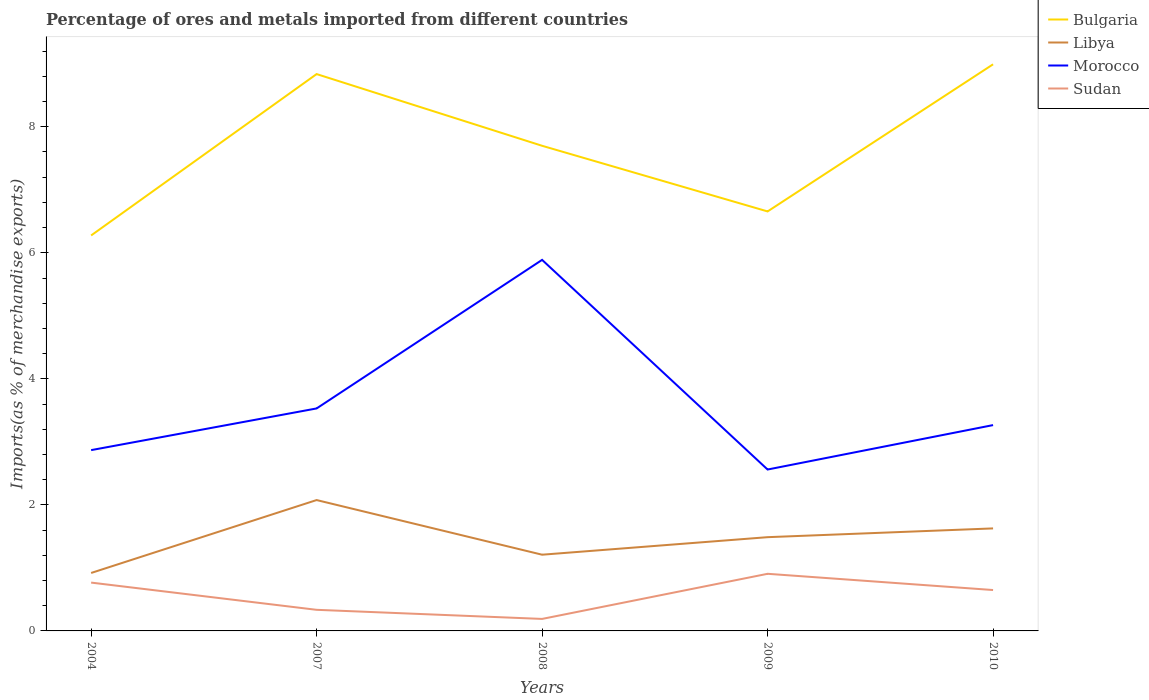Does the line corresponding to Morocco intersect with the line corresponding to Libya?
Offer a very short reply. No. Across all years, what is the maximum percentage of imports to different countries in Morocco?
Provide a succinct answer. 2.56. What is the total percentage of imports to different countries in Sudan in the graph?
Provide a short and direct response. 0.58. What is the difference between the highest and the second highest percentage of imports to different countries in Libya?
Offer a very short reply. 1.16. How many lines are there?
Your answer should be compact. 4. How many years are there in the graph?
Provide a succinct answer. 5. How many legend labels are there?
Make the answer very short. 4. What is the title of the graph?
Your response must be concise. Percentage of ores and metals imported from different countries. What is the label or title of the X-axis?
Give a very brief answer. Years. What is the label or title of the Y-axis?
Offer a terse response. Imports(as % of merchandise exports). What is the Imports(as % of merchandise exports) of Bulgaria in 2004?
Make the answer very short. 6.28. What is the Imports(as % of merchandise exports) in Libya in 2004?
Keep it short and to the point. 0.92. What is the Imports(as % of merchandise exports) of Morocco in 2004?
Offer a terse response. 2.87. What is the Imports(as % of merchandise exports) of Sudan in 2004?
Ensure brevity in your answer.  0.77. What is the Imports(as % of merchandise exports) of Bulgaria in 2007?
Give a very brief answer. 8.84. What is the Imports(as % of merchandise exports) of Libya in 2007?
Keep it short and to the point. 2.08. What is the Imports(as % of merchandise exports) of Morocco in 2007?
Offer a very short reply. 3.53. What is the Imports(as % of merchandise exports) in Sudan in 2007?
Provide a short and direct response. 0.33. What is the Imports(as % of merchandise exports) in Bulgaria in 2008?
Provide a short and direct response. 7.7. What is the Imports(as % of merchandise exports) of Libya in 2008?
Your answer should be very brief. 1.21. What is the Imports(as % of merchandise exports) in Morocco in 2008?
Keep it short and to the point. 5.89. What is the Imports(as % of merchandise exports) in Sudan in 2008?
Provide a short and direct response. 0.19. What is the Imports(as % of merchandise exports) in Bulgaria in 2009?
Provide a succinct answer. 6.66. What is the Imports(as % of merchandise exports) in Libya in 2009?
Provide a succinct answer. 1.49. What is the Imports(as % of merchandise exports) in Morocco in 2009?
Give a very brief answer. 2.56. What is the Imports(as % of merchandise exports) of Sudan in 2009?
Provide a short and direct response. 0.91. What is the Imports(as % of merchandise exports) of Bulgaria in 2010?
Provide a short and direct response. 8.99. What is the Imports(as % of merchandise exports) in Libya in 2010?
Your response must be concise. 1.63. What is the Imports(as % of merchandise exports) of Morocco in 2010?
Your response must be concise. 3.27. What is the Imports(as % of merchandise exports) of Sudan in 2010?
Give a very brief answer. 0.65. Across all years, what is the maximum Imports(as % of merchandise exports) of Bulgaria?
Your response must be concise. 8.99. Across all years, what is the maximum Imports(as % of merchandise exports) of Libya?
Ensure brevity in your answer.  2.08. Across all years, what is the maximum Imports(as % of merchandise exports) of Morocco?
Provide a short and direct response. 5.89. Across all years, what is the maximum Imports(as % of merchandise exports) of Sudan?
Your answer should be very brief. 0.91. Across all years, what is the minimum Imports(as % of merchandise exports) in Bulgaria?
Provide a short and direct response. 6.28. Across all years, what is the minimum Imports(as % of merchandise exports) of Libya?
Make the answer very short. 0.92. Across all years, what is the minimum Imports(as % of merchandise exports) in Morocco?
Offer a terse response. 2.56. Across all years, what is the minimum Imports(as % of merchandise exports) of Sudan?
Offer a very short reply. 0.19. What is the total Imports(as % of merchandise exports) in Bulgaria in the graph?
Your answer should be compact. 38.46. What is the total Imports(as % of merchandise exports) in Libya in the graph?
Offer a very short reply. 7.32. What is the total Imports(as % of merchandise exports) of Morocco in the graph?
Offer a terse response. 18.11. What is the total Imports(as % of merchandise exports) of Sudan in the graph?
Your response must be concise. 2.85. What is the difference between the Imports(as % of merchandise exports) of Bulgaria in 2004 and that in 2007?
Provide a short and direct response. -2.56. What is the difference between the Imports(as % of merchandise exports) in Libya in 2004 and that in 2007?
Your answer should be very brief. -1.16. What is the difference between the Imports(as % of merchandise exports) of Morocco in 2004 and that in 2007?
Your response must be concise. -0.66. What is the difference between the Imports(as % of merchandise exports) in Sudan in 2004 and that in 2007?
Your answer should be compact. 0.43. What is the difference between the Imports(as % of merchandise exports) in Bulgaria in 2004 and that in 2008?
Keep it short and to the point. -1.42. What is the difference between the Imports(as % of merchandise exports) of Libya in 2004 and that in 2008?
Ensure brevity in your answer.  -0.29. What is the difference between the Imports(as % of merchandise exports) of Morocco in 2004 and that in 2008?
Your answer should be very brief. -3.02. What is the difference between the Imports(as % of merchandise exports) of Sudan in 2004 and that in 2008?
Provide a succinct answer. 0.58. What is the difference between the Imports(as % of merchandise exports) of Bulgaria in 2004 and that in 2009?
Offer a very short reply. -0.38. What is the difference between the Imports(as % of merchandise exports) in Libya in 2004 and that in 2009?
Offer a terse response. -0.57. What is the difference between the Imports(as % of merchandise exports) in Morocco in 2004 and that in 2009?
Your answer should be compact. 0.31. What is the difference between the Imports(as % of merchandise exports) of Sudan in 2004 and that in 2009?
Provide a short and direct response. -0.14. What is the difference between the Imports(as % of merchandise exports) in Bulgaria in 2004 and that in 2010?
Offer a very short reply. -2.72. What is the difference between the Imports(as % of merchandise exports) in Libya in 2004 and that in 2010?
Provide a short and direct response. -0.71. What is the difference between the Imports(as % of merchandise exports) of Morocco in 2004 and that in 2010?
Make the answer very short. -0.4. What is the difference between the Imports(as % of merchandise exports) in Sudan in 2004 and that in 2010?
Your answer should be compact. 0.12. What is the difference between the Imports(as % of merchandise exports) of Bulgaria in 2007 and that in 2008?
Ensure brevity in your answer.  1.14. What is the difference between the Imports(as % of merchandise exports) of Libya in 2007 and that in 2008?
Ensure brevity in your answer.  0.87. What is the difference between the Imports(as % of merchandise exports) of Morocco in 2007 and that in 2008?
Offer a very short reply. -2.36. What is the difference between the Imports(as % of merchandise exports) in Sudan in 2007 and that in 2008?
Your answer should be compact. 0.14. What is the difference between the Imports(as % of merchandise exports) in Bulgaria in 2007 and that in 2009?
Offer a very short reply. 2.18. What is the difference between the Imports(as % of merchandise exports) of Libya in 2007 and that in 2009?
Give a very brief answer. 0.59. What is the difference between the Imports(as % of merchandise exports) of Morocco in 2007 and that in 2009?
Ensure brevity in your answer.  0.97. What is the difference between the Imports(as % of merchandise exports) in Sudan in 2007 and that in 2009?
Your answer should be very brief. -0.57. What is the difference between the Imports(as % of merchandise exports) of Bulgaria in 2007 and that in 2010?
Give a very brief answer. -0.16. What is the difference between the Imports(as % of merchandise exports) in Libya in 2007 and that in 2010?
Offer a terse response. 0.45. What is the difference between the Imports(as % of merchandise exports) of Morocco in 2007 and that in 2010?
Your response must be concise. 0.26. What is the difference between the Imports(as % of merchandise exports) in Sudan in 2007 and that in 2010?
Offer a terse response. -0.31. What is the difference between the Imports(as % of merchandise exports) in Bulgaria in 2008 and that in 2009?
Your response must be concise. 1.04. What is the difference between the Imports(as % of merchandise exports) in Libya in 2008 and that in 2009?
Ensure brevity in your answer.  -0.28. What is the difference between the Imports(as % of merchandise exports) in Morocco in 2008 and that in 2009?
Keep it short and to the point. 3.33. What is the difference between the Imports(as % of merchandise exports) of Sudan in 2008 and that in 2009?
Provide a short and direct response. -0.72. What is the difference between the Imports(as % of merchandise exports) of Bulgaria in 2008 and that in 2010?
Offer a very short reply. -1.29. What is the difference between the Imports(as % of merchandise exports) of Libya in 2008 and that in 2010?
Your answer should be very brief. -0.42. What is the difference between the Imports(as % of merchandise exports) in Morocco in 2008 and that in 2010?
Give a very brief answer. 2.62. What is the difference between the Imports(as % of merchandise exports) in Sudan in 2008 and that in 2010?
Provide a succinct answer. -0.46. What is the difference between the Imports(as % of merchandise exports) of Bulgaria in 2009 and that in 2010?
Give a very brief answer. -2.33. What is the difference between the Imports(as % of merchandise exports) of Libya in 2009 and that in 2010?
Your answer should be very brief. -0.14. What is the difference between the Imports(as % of merchandise exports) of Morocco in 2009 and that in 2010?
Your response must be concise. -0.7. What is the difference between the Imports(as % of merchandise exports) of Sudan in 2009 and that in 2010?
Keep it short and to the point. 0.26. What is the difference between the Imports(as % of merchandise exports) in Bulgaria in 2004 and the Imports(as % of merchandise exports) in Libya in 2007?
Offer a very short reply. 4.2. What is the difference between the Imports(as % of merchandise exports) in Bulgaria in 2004 and the Imports(as % of merchandise exports) in Morocco in 2007?
Provide a succinct answer. 2.74. What is the difference between the Imports(as % of merchandise exports) of Bulgaria in 2004 and the Imports(as % of merchandise exports) of Sudan in 2007?
Offer a very short reply. 5.94. What is the difference between the Imports(as % of merchandise exports) of Libya in 2004 and the Imports(as % of merchandise exports) of Morocco in 2007?
Give a very brief answer. -2.61. What is the difference between the Imports(as % of merchandise exports) in Libya in 2004 and the Imports(as % of merchandise exports) in Sudan in 2007?
Your answer should be very brief. 0.58. What is the difference between the Imports(as % of merchandise exports) of Morocco in 2004 and the Imports(as % of merchandise exports) of Sudan in 2007?
Your response must be concise. 2.53. What is the difference between the Imports(as % of merchandise exports) in Bulgaria in 2004 and the Imports(as % of merchandise exports) in Libya in 2008?
Your answer should be very brief. 5.07. What is the difference between the Imports(as % of merchandise exports) in Bulgaria in 2004 and the Imports(as % of merchandise exports) in Morocco in 2008?
Your answer should be very brief. 0.39. What is the difference between the Imports(as % of merchandise exports) in Bulgaria in 2004 and the Imports(as % of merchandise exports) in Sudan in 2008?
Ensure brevity in your answer.  6.08. What is the difference between the Imports(as % of merchandise exports) in Libya in 2004 and the Imports(as % of merchandise exports) in Morocco in 2008?
Offer a terse response. -4.97. What is the difference between the Imports(as % of merchandise exports) of Libya in 2004 and the Imports(as % of merchandise exports) of Sudan in 2008?
Offer a very short reply. 0.73. What is the difference between the Imports(as % of merchandise exports) in Morocco in 2004 and the Imports(as % of merchandise exports) in Sudan in 2008?
Offer a terse response. 2.68. What is the difference between the Imports(as % of merchandise exports) in Bulgaria in 2004 and the Imports(as % of merchandise exports) in Libya in 2009?
Offer a terse response. 4.79. What is the difference between the Imports(as % of merchandise exports) of Bulgaria in 2004 and the Imports(as % of merchandise exports) of Morocco in 2009?
Offer a terse response. 3.71. What is the difference between the Imports(as % of merchandise exports) of Bulgaria in 2004 and the Imports(as % of merchandise exports) of Sudan in 2009?
Offer a very short reply. 5.37. What is the difference between the Imports(as % of merchandise exports) in Libya in 2004 and the Imports(as % of merchandise exports) in Morocco in 2009?
Give a very brief answer. -1.64. What is the difference between the Imports(as % of merchandise exports) of Libya in 2004 and the Imports(as % of merchandise exports) of Sudan in 2009?
Ensure brevity in your answer.  0.01. What is the difference between the Imports(as % of merchandise exports) in Morocco in 2004 and the Imports(as % of merchandise exports) in Sudan in 2009?
Your answer should be very brief. 1.96. What is the difference between the Imports(as % of merchandise exports) in Bulgaria in 2004 and the Imports(as % of merchandise exports) in Libya in 2010?
Keep it short and to the point. 4.65. What is the difference between the Imports(as % of merchandise exports) in Bulgaria in 2004 and the Imports(as % of merchandise exports) in Morocco in 2010?
Keep it short and to the point. 3.01. What is the difference between the Imports(as % of merchandise exports) of Bulgaria in 2004 and the Imports(as % of merchandise exports) of Sudan in 2010?
Make the answer very short. 5.63. What is the difference between the Imports(as % of merchandise exports) of Libya in 2004 and the Imports(as % of merchandise exports) of Morocco in 2010?
Make the answer very short. -2.35. What is the difference between the Imports(as % of merchandise exports) in Libya in 2004 and the Imports(as % of merchandise exports) in Sudan in 2010?
Ensure brevity in your answer.  0.27. What is the difference between the Imports(as % of merchandise exports) of Morocco in 2004 and the Imports(as % of merchandise exports) of Sudan in 2010?
Keep it short and to the point. 2.22. What is the difference between the Imports(as % of merchandise exports) of Bulgaria in 2007 and the Imports(as % of merchandise exports) of Libya in 2008?
Give a very brief answer. 7.63. What is the difference between the Imports(as % of merchandise exports) of Bulgaria in 2007 and the Imports(as % of merchandise exports) of Morocco in 2008?
Ensure brevity in your answer.  2.95. What is the difference between the Imports(as % of merchandise exports) of Bulgaria in 2007 and the Imports(as % of merchandise exports) of Sudan in 2008?
Your response must be concise. 8.65. What is the difference between the Imports(as % of merchandise exports) of Libya in 2007 and the Imports(as % of merchandise exports) of Morocco in 2008?
Provide a short and direct response. -3.81. What is the difference between the Imports(as % of merchandise exports) of Libya in 2007 and the Imports(as % of merchandise exports) of Sudan in 2008?
Offer a terse response. 1.89. What is the difference between the Imports(as % of merchandise exports) in Morocco in 2007 and the Imports(as % of merchandise exports) in Sudan in 2008?
Give a very brief answer. 3.34. What is the difference between the Imports(as % of merchandise exports) in Bulgaria in 2007 and the Imports(as % of merchandise exports) in Libya in 2009?
Provide a short and direct response. 7.35. What is the difference between the Imports(as % of merchandise exports) of Bulgaria in 2007 and the Imports(as % of merchandise exports) of Morocco in 2009?
Provide a short and direct response. 6.27. What is the difference between the Imports(as % of merchandise exports) of Bulgaria in 2007 and the Imports(as % of merchandise exports) of Sudan in 2009?
Keep it short and to the point. 7.93. What is the difference between the Imports(as % of merchandise exports) of Libya in 2007 and the Imports(as % of merchandise exports) of Morocco in 2009?
Provide a succinct answer. -0.48. What is the difference between the Imports(as % of merchandise exports) of Libya in 2007 and the Imports(as % of merchandise exports) of Sudan in 2009?
Provide a succinct answer. 1.17. What is the difference between the Imports(as % of merchandise exports) in Morocco in 2007 and the Imports(as % of merchandise exports) in Sudan in 2009?
Give a very brief answer. 2.62. What is the difference between the Imports(as % of merchandise exports) in Bulgaria in 2007 and the Imports(as % of merchandise exports) in Libya in 2010?
Offer a terse response. 7.21. What is the difference between the Imports(as % of merchandise exports) in Bulgaria in 2007 and the Imports(as % of merchandise exports) in Morocco in 2010?
Provide a succinct answer. 5.57. What is the difference between the Imports(as % of merchandise exports) in Bulgaria in 2007 and the Imports(as % of merchandise exports) in Sudan in 2010?
Ensure brevity in your answer.  8.19. What is the difference between the Imports(as % of merchandise exports) in Libya in 2007 and the Imports(as % of merchandise exports) in Morocco in 2010?
Offer a very short reply. -1.19. What is the difference between the Imports(as % of merchandise exports) in Libya in 2007 and the Imports(as % of merchandise exports) in Sudan in 2010?
Provide a short and direct response. 1.43. What is the difference between the Imports(as % of merchandise exports) in Morocco in 2007 and the Imports(as % of merchandise exports) in Sudan in 2010?
Provide a short and direct response. 2.88. What is the difference between the Imports(as % of merchandise exports) of Bulgaria in 2008 and the Imports(as % of merchandise exports) of Libya in 2009?
Offer a terse response. 6.21. What is the difference between the Imports(as % of merchandise exports) of Bulgaria in 2008 and the Imports(as % of merchandise exports) of Morocco in 2009?
Provide a succinct answer. 5.14. What is the difference between the Imports(as % of merchandise exports) in Bulgaria in 2008 and the Imports(as % of merchandise exports) in Sudan in 2009?
Keep it short and to the point. 6.79. What is the difference between the Imports(as % of merchandise exports) of Libya in 2008 and the Imports(as % of merchandise exports) of Morocco in 2009?
Your response must be concise. -1.35. What is the difference between the Imports(as % of merchandise exports) of Libya in 2008 and the Imports(as % of merchandise exports) of Sudan in 2009?
Give a very brief answer. 0.3. What is the difference between the Imports(as % of merchandise exports) in Morocco in 2008 and the Imports(as % of merchandise exports) in Sudan in 2009?
Provide a short and direct response. 4.98. What is the difference between the Imports(as % of merchandise exports) of Bulgaria in 2008 and the Imports(as % of merchandise exports) of Libya in 2010?
Your response must be concise. 6.07. What is the difference between the Imports(as % of merchandise exports) in Bulgaria in 2008 and the Imports(as % of merchandise exports) in Morocco in 2010?
Your answer should be compact. 4.43. What is the difference between the Imports(as % of merchandise exports) of Bulgaria in 2008 and the Imports(as % of merchandise exports) of Sudan in 2010?
Ensure brevity in your answer.  7.05. What is the difference between the Imports(as % of merchandise exports) of Libya in 2008 and the Imports(as % of merchandise exports) of Morocco in 2010?
Make the answer very short. -2.06. What is the difference between the Imports(as % of merchandise exports) in Libya in 2008 and the Imports(as % of merchandise exports) in Sudan in 2010?
Your response must be concise. 0.56. What is the difference between the Imports(as % of merchandise exports) of Morocco in 2008 and the Imports(as % of merchandise exports) of Sudan in 2010?
Provide a succinct answer. 5.24. What is the difference between the Imports(as % of merchandise exports) of Bulgaria in 2009 and the Imports(as % of merchandise exports) of Libya in 2010?
Your answer should be very brief. 5.03. What is the difference between the Imports(as % of merchandise exports) in Bulgaria in 2009 and the Imports(as % of merchandise exports) in Morocco in 2010?
Make the answer very short. 3.39. What is the difference between the Imports(as % of merchandise exports) in Bulgaria in 2009 and the Imports(as % of merchandise exports) in Sudan in 2010?
Provide a short and direct response. 6.01. What is the difference between the Imports(as % of merchandise exports) in Libya in 2009 and the Imports(as % of merchandise exports) in Morocco in 2010?
Keep it short and to the point. -1.78. What is the difference between the Imports(as % of merchandise exports) in Libya in 2009 and the Imports(as % of merchandise exports) in Sudan in 2010?
Offer a very short reply. 0.84. What is the difference between the Imports(as % of merchandise exports) of Morocco in 2009 and the Imports(as % of merchandise exports) of Sudan in 2010?
Make the answer very short. 1.91. What is the average Imports(as % of merchandise exports) in Bulgaria per year?
Offer a terse response. 7.69. What is the average Imports(as % of merchandise exports) of Libya per year?
Give a very brief answer. 1.46. What is the average Imports(as % of merchandise exports) in Morocco per year?
Provide a succinct answer. 3.62. What is the average Imports(as % of merchandise exports) of Sudan per year?
Your answer should be compact. 0.57. In the year 2004, what is the difference between the Imports(as % of merchandise exports) of Bulgaria and Imports(as % of merchandise exports) of Libya?
Your answer should be very brief. 5.36. In the year 2004, what is the difference between the Imports(as % of merchandise exports) of Bulgaria and Imports(as % of merchandise exports) of Morocco?
Give a very brief answer. 3.41. In the year 2004, what is the difference between the Imports(as % of merchandise exports) of Bulgaria and Imports(as % of merchandise exports) of Sudan?
Provide a succinct answer. 5.51. In the year 2004, what is the difference between the Imports(as % of merchandise exports) of Libya and Imports(as % of merchandise exports) of Morocco?
Ensure brevity in your answer.  -1.95. In the year 2004, what is the difference between the Imports(as % of merchandise exports) of Libya and Imports(as % of merchandise exports) of Sudan?
Give a very brief answer. 0.15. In the year 2004, what is the difference between the Imports(as % of merchandise exports) of Morocco and Imports(as % of merchandise exports) of Sudan?
Your answer should be very brief. 2.1. In the year 2007, what is the difference between the Imports(as % of merchandise exports) in Bulgaria and Imports(as % of merchandise exports) in Libya?
Your response must be concise. 6.76. In the year 2007, what is the difference between the Imports(as % of merchandise exports) in Bulgaria and Imports(as % of merchandise exports) in Morocco?
Offer a very short reply. 5.31. In the year 2007, what is the difference between the Imports(as % of merchandise exports) in Bulgaria and Imports(as % of merchandise exports) in Sudan?
Your answer should be very brief. 8.5. In the year 2007, what is the difference between the Imports(as % of merchandise exports) in Libya and Imports(as % of merchandise exports) in Morocco?
Offer a very short reply. -1.45. In the year 2007, what is the difference between the Imports(as % of merchandise exports) of Libya and Imports(as % of merchandise exports) of Sudan?
Ensure brevity in your answer.  1.74. In the year 2007, what is the difference between the Imports(as % of merchandise exports) of Morocco and Imports(as % of merchandise exports) of Sudan?
Keep it short and to the point. 3.2. In the year 2008, what is the difference between the Imports(as % of merchandise exports) in Bulgaria and Imports(as % of merchandise exports) in Libya?
Keep it short and to the point. 6.49. In the year 2008, what is the difference between the Imports(as % of merchandise exports) of Bulgaria and Imports(as % of merchandise exports) of Morocco?
Offer a terse response. 1.81. In the year 2008, what is the difference between the Imports(as % of merchandise exports) in Bulgaria and Imports(as % of merchandise exports) in Sudan?
Ensure brevity in your answer.  7.51. In the year 2008, what is the difference between the Imports(as % of merchandise exports) of Libya and Imports(as % of merchandise exports) of Morocco?
Offer a terse response. -4.68. In the year 2008, what is the difference between the Imports(as % of merchandise exports) in Morocco and Imports(as % of merchandise exports) in Sudan?
Provide a short and direct response. 5.7. In the year 2009, what is the difference between the Imports(as % of merchandise exports) of Bulgaria and Imports(as % of merchandise exports) of Libya?
Provide a succinct answer. 5.17. In the year 2009, what is the difference between the Imports(as % of merchandise exports) of Bulgaria and Imports(as % of merchandise exports) of Morocco?
Make the answer very short. 4.1. In the year 2009, what is the difference between the Imports(as % of merchandise exports) in Bulgaria and Imports(as % of merchandise exports) in Sudan?
Provide a short and direct response. 5.75. In the year 2009, what is the difference between the Imports(as % of merchandise exports) of Libya and Imports(as % of merchandise exports) of Morocco?
Keep it short and to the point. -1.07. In the year 2009, what is the difference between the Imports(as % of merchandise exports) of Libya and Imports(as % of merchandise exports) of Sudan?
Make the answer very short. 0.58. In the year 2009, what is the difference between the Imports(as % of merchandise exports) of Morocco and Imports(as % of merchandise exports) of Sudan?
Provide a short and direct response. 1.65. In the year 2010, what is the difference between the Imports(as % of merchandise exports) in Bulgaria and Imports(as % of merchandise exports) in Libya?
Your response must be concise. 7.36. In the year 2010, what is the difference between the Imports(as % of merchandise exports) of Bulgaria and Imports(as % of merchandise exports) of Morocco?
Your answer should be compact. 5.72. In the year 2010, what is the difference between the Imports(as % of merchandise exports) in Bulgaria and Imports(as % of merchandise exports) in Sudan?
Make the answer very short. 8.34. In the year 2010, what is the difference between the Imports(as % of merchandise exports) of Libya and Imports(as % of merchandise exports) of Morocco?
Your answer should be very brief. -1.64. In the year 2010, what is the difference between the Imports(as % of merchandise exports) of Libya and Imports(as % of merchandise exports) of Sudan?
Provide a succinct answer. 0.98. In the year 2010, what is the difference between the Imports(as % of merchandise exports) in Morocco and Imports(as % of merchandise exports) in Sudan?
Your answer should be very brief. 2.62. What is the ratio of the Imports(as % of merchandise exports) in Bulgaria in 2004 to that in 2007?
Your answer should be compact. 0.71. What is the ratio of the Imports(as % of merchandise exports) in Libya in 2004 to that in 2007?
Provide a short and direct response. 0.44. What is the ratio of the Imports(as % of merchandise exports) in Morocco in 2004 to that in 2007?
Make the answer very short. 0.81. What is the ratio of the Imports(as % of merchandise exports) of Sudan in 2004 to that in 2007?
Ensure brevity in your answer.  2.29. What is the ratio of the Imports(as % of merchandise exports) of Bulgaria in 2004 to that in 2008?
Provide a short and direct response. 0.82. What is the ratio of the Imports(as % of merchandise exports) in Libya in 2004 to that in 2008?
Provide a short and direct response. 0.76. What is the ratio of the Imports(as % of merchandise exports) in Morocco in 2004 to that in 2008?
Offer a terse response. 0.49. What is the ratio of the Imports(as % of merchandise exports) in Sudan in 2004 to that in 2008?
Your answer should be compact. 4.03. What is the ratio of the Imports(as % of merchandise exports) of Bulgaria in 2004 to that in 2009?
Give a very brief answer. 0.94. What is the ratio of the Imports(as % of merchandise exports) of Libya in 2004 to that in 2009?
Your answer should be compact. 0.62. What is the ratio of the Imports(as % of merchandise exports) in Morocco in 2004 to that in 2009?
Your response must be concise. 1.12. What is the ratio of the Imports(as % of merchandise exports) in Sudan in 2004 to that in 2009?
Your answer should be compact. 0.85. What is the ratio of the Imports(as % of merchandise exports) of Bulgaria in 2004 to that in 2010?
Ensure brevity in your answer.  0.7. What is the ratio of the Imports(as % of merchandise exports) of Libya in 2004 to that in 2010?
Give a very brief answer. 0.57. What is the ratio of the Imports(as % of merchandise exports) of Morocco in 2004 to that in 2010?
Give a very brief answer. 0.88. What is the ratio of the Imports(as % of merchandise exports) of Sudan in 2004 to that in 2010?
Your response must be concise. 1.18. What is the ratio of the Imports(as % of merchandise exports) of Bulgaria in 2007 to that in 2008?
Provide a short and direct response. 1.15. What is the ratio of the Imports(as % of merchandise exports) in Libya in 2007 to that in 2008?
Your answer should be very brief. 1.72. What is the ratio of the Imports(as % of merchandise exports) of Morocco in 2007 to that in 2008?
Your answer should be very brief. 0.6. What is the ratio of the Imports(as % of merchandise exports) in Sudan in 2007 to that in 2008?
Offer a very short reply. 1.76. What is the ratio of the Imports(as % of merchandise exports) of Bulgaria in 2007 to that in 2009?
Ensure brevity in your answer.  1.33. What is the ratio of the Imports(as % of merchandise exports) of Libya in 2007 to that in 2009?
Ensure brevity in your answer.  1.4. What is the ratio of the Imports(as % of merchandise exports) of Morocco in 2007 to that in 2009?
Make the answer very short. 1.38. What is the ratio of the Imports(as % of merchandise exports) in Sudan in 2007 to that in 2009?
Your answer should be compact. 0.37. What is the ratio of the Imports(as % of merchandise exports) in Bulgaria in 2007 to that in 2010?
Make the answer very short. 0.98. What is the ratio of the Imports(as % of merchandise exports) in Libya in 2007 to that in 2010?
Give a very brief answer. 1.28. What is the ratio of the Imports(as % of merchandise exports) of Morocco in 2007 to that in 2010?
Give a very brief answer. 1.08. What is the ratio of the Imports(as % of merchandise exports) of Sudan in 2007 to that in 2010?
Offer a very short reply. 0.52. What is the ratio of the Imports(as % of merchandise exports) in Bulgaria in 2008 to that in 2009?
Ensure brevity in your answer.  1.16. What is the ratio of the Imports(as % of merchandise exports) of Libya in 2008 to that in 2009?
Your answer should be very brief. 0.81. What is the ratio of the Imports(as % of merchandise exports) of Morocco in 2008 to that in 2009?
Your response must be concise. 2.3. What is the ratio of the Imports(as % of merchandise exports) in Sudan in 2008 to that in 2009?
Your answer should be compact. 0.21. What is the ratio of the Imports(as % of merchandise exports) in Bulgaria in 2008 to that in 2010?
Your response must be concise. 0.86. What is the ratio of the Imports(as % of merchandise exports) of Libya in 2008 to that in 2010?
Give a very brief answer. 0.74. What is the ratio of the Imports(as % of merchandise exports) in Morocco in 2008 to that in 2010?
Your response must be concise. 1.8. What is the ratio of the Imports(as % of merchandise exports) of Sudan in 2008 to that in 2010?
Your answer should be compact. 0.29. What is the ratio of the Imports(as % of merchandise exports) of Bulgaria in 2009 to that in 2010?
Offer a terse response. 0.74. What is the ratio of the Imports(as % of merchandise exports) of Libya in 2009 to that in 2010?
Provide a succinct answer. 0.91. What is the ratio of the Imports(as % of merchandise exports) in Morocco in 2009 to that in 2010?
Offer a very short reply. 0.78. What is the ratio of the Imports(as % of merchandise exports) of Sudan in 2009 to that in 2010?
Make the answer very short. 1.4. What is the difference between the highest and the second highest Imports(as % of merchandise exports) in Bulgaria?
Your answer should be very brief. 0.16. What is the difference between the highest and the second highest Imports(as % of merchandise exports) of Libya?
Provide a short and direct response. 0.45. What is the difference between the highest and the second highest Imports(as % of merchandise exports) of Morocco?
Make the answer very short. 2.36. What is the difference between the highest and the second highest Imports(as % of merchandise exports) of Sudan?
Give a very brief answer. 0.14. What is the difference between the highest and the lowest Imports(as % of merchandise exports) of Bulgaria?
Your response must be concise. 2.72. What is the difference between the highest and the lowest Imports(as % of merchandise exports) of Libya?
Your response must be concise. 1.16. What is the difference between the highest and the lowest Imports(as % of merchandise exports) in Morocco?
Make the answer very short. 3.33. What is the difference between the highest and the lowest Imports(as % of merchandise exports) in Sudan?
Your response must be concise. 0.72. 